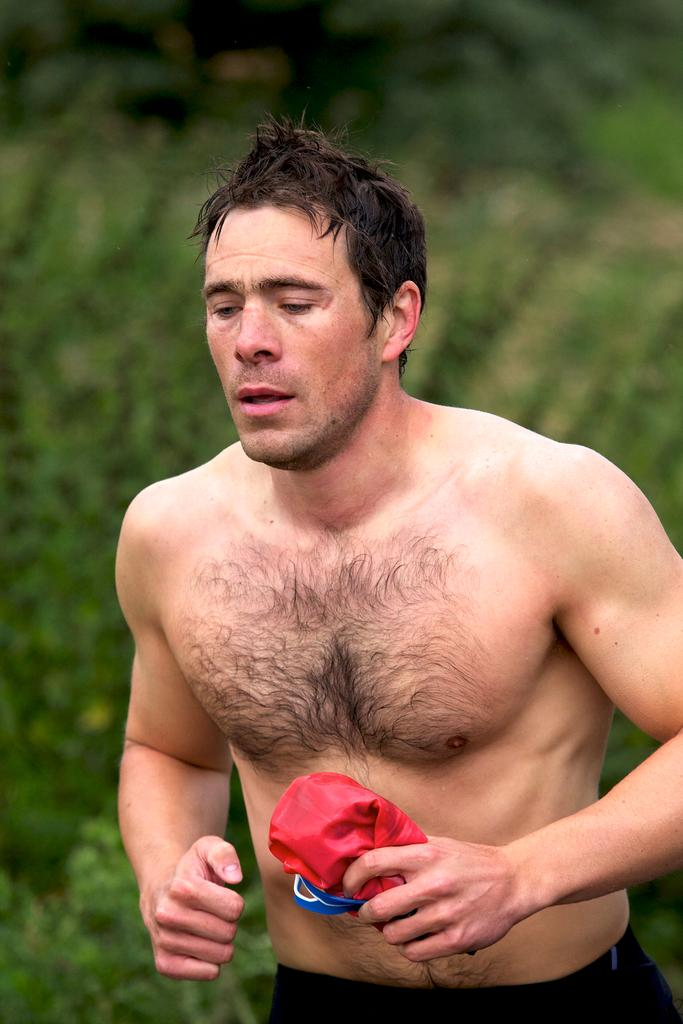Who or what is the main subject in the image? There is a person in the image. What is the person holding in the image? The person is holding a red and blue color cloth. What color is the background of the image? The background of the image is green. What theory is the hen discussing with the person in the image? There is no hen present in the image, so there is no discussion about any theory. 